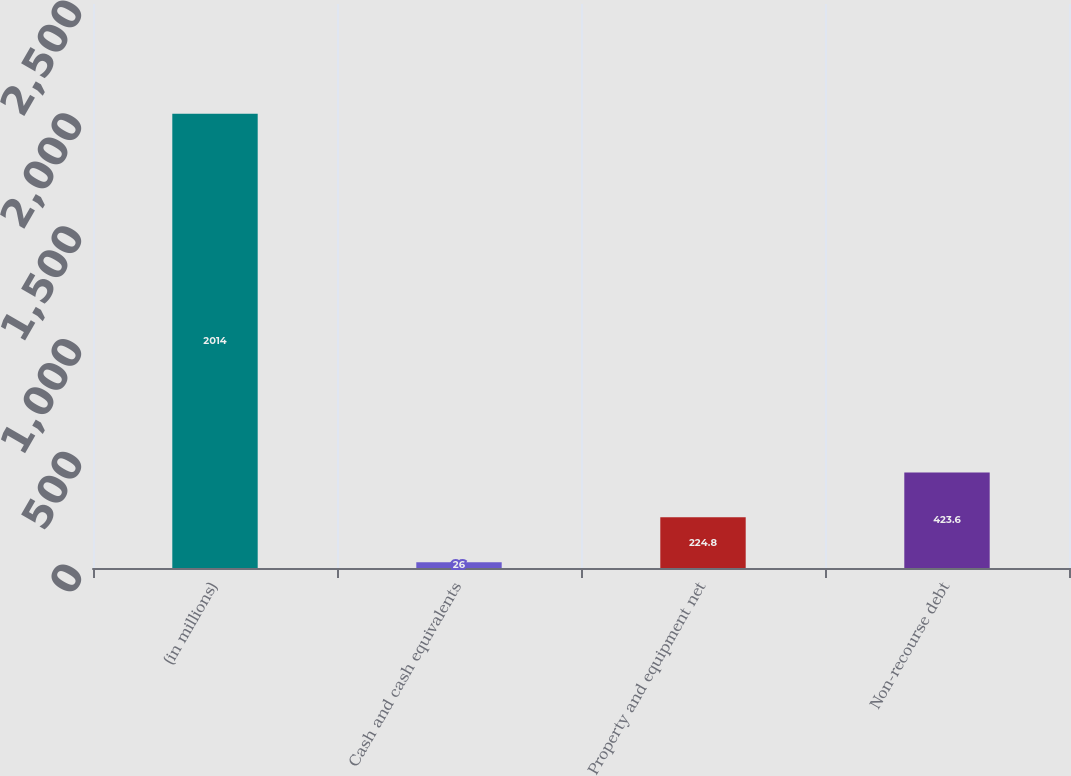Convert chart to OTSL. <chart><loc_0><loc_0><loc_500><loc_500><bar_chart><fcel>(in millions)<fcel>Cash and cash equivalents<fcel>Property and equipment net<fcel>Non-recourse debt<nl><fcel>2014<fcel>26<fcel>224.8<fcel>423.6<nl></chart> 